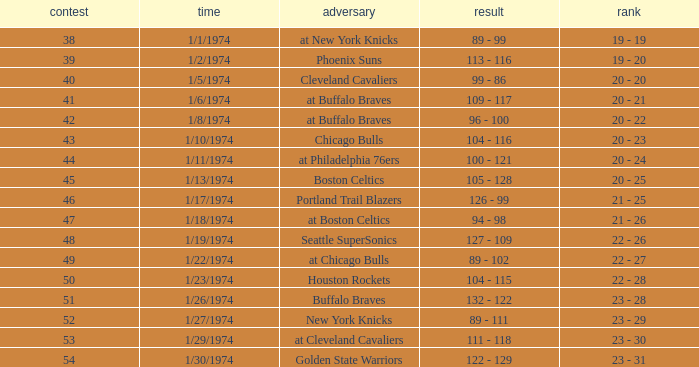What was the score on 1/10/1974? 104 - 116. 